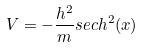Convert formula to latex. <formula><loc_0><loc_0><loc_500><loc_500>V = - \frac { h ^ { 2 } } { m } s e c h ^ { 2 } ( x )</formula> 